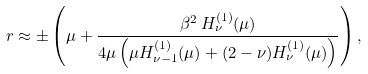Convert formula to latex. <formula><loc_0><loc_0><loc_500><loc_500>\ r \approx \pm \left ( \mu + \frac { \beta ^ { 2 } \, H _ { \nu } ^ { ( 1 ) } ( \mu ) } { 4 \mu \left ( \mu H _ { \nu - 1 } ^ { ( 1 ) } ( \mu ) + ( 2 - \nu ) H _ { \nu } ^ { ( 1 ) } ( \mu ) \right ) } \right ) ,</formula> 